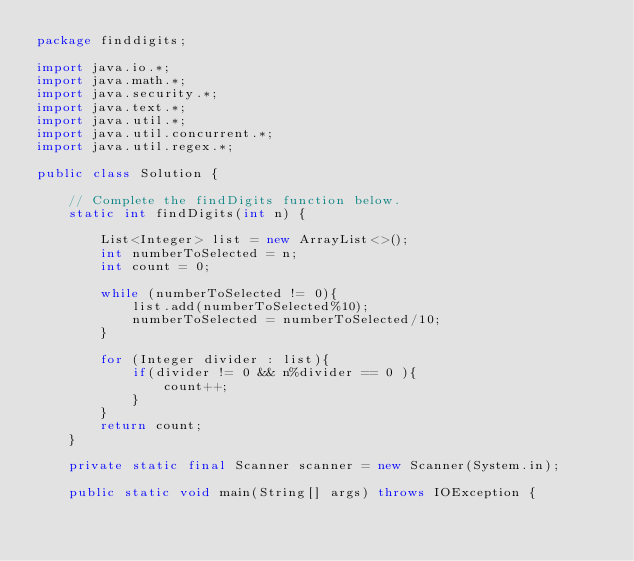Convert code to text. <code><loc_0><loc_0><loc_500><loc_500><_Java_>package finddigits;

import java.io.*;
import java.math.*;
import java.security.*;
import java.text.*;
import java.util.*;
import java.util.concurrent.*;
import java.util.regex.*;

public class Solution {

    // Complete the findDigits function below.
    static int findDigits(int n) {

        List<Integer> list = new ArrayList<>();
        int numberToSelected = n;
        int count = 0;

        while (numberToSelected != 0){
            list.add(numberToSelected%10);
            numberToSelected = numberToSelected/10;
        }

        for (Integer divider : list){
            if(divider != 0 && n%divider == 0 ){
                count++;
            }
        }
        return count;
    }

    private static final Scanner scanner = new Scanner(System.in);

    public static void main(String[] args) throws IOException {</code> 